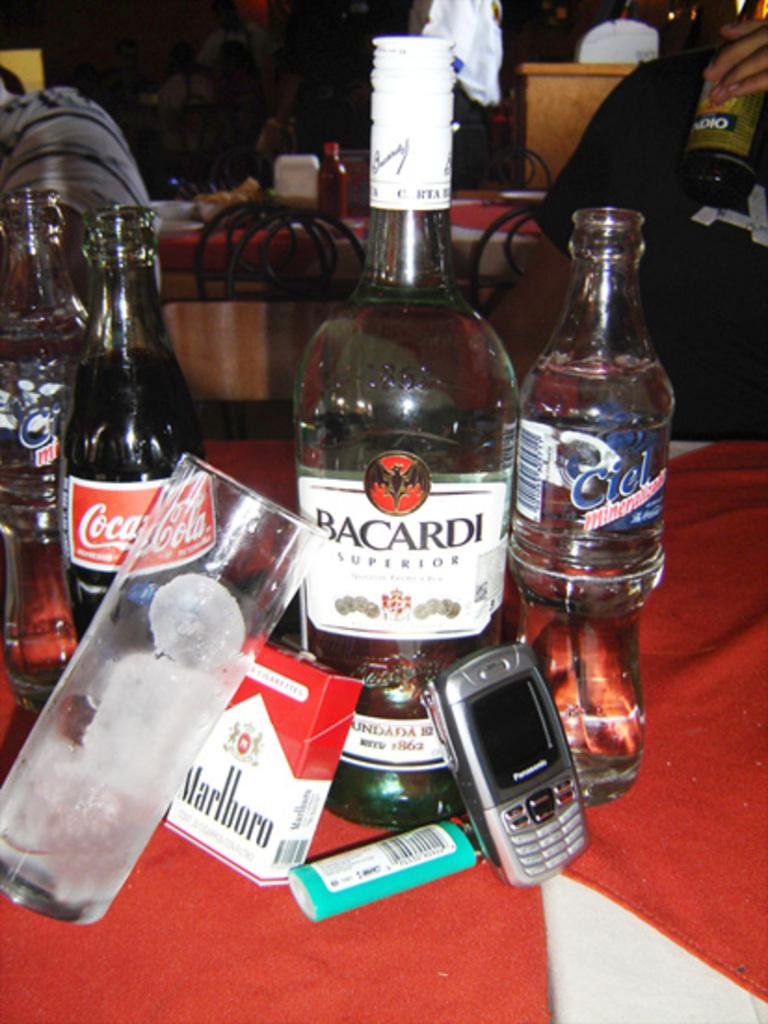<image>
Provide a brief description of the given image. A table has a bunch of bottles, a cell phone, a lighter, and a pack of cigarettes that says Marlboro. 